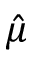Convert formula to latex. <formula><loc_0><loc_0><loc_500><loc_500>\hat { \mu }</formula> 